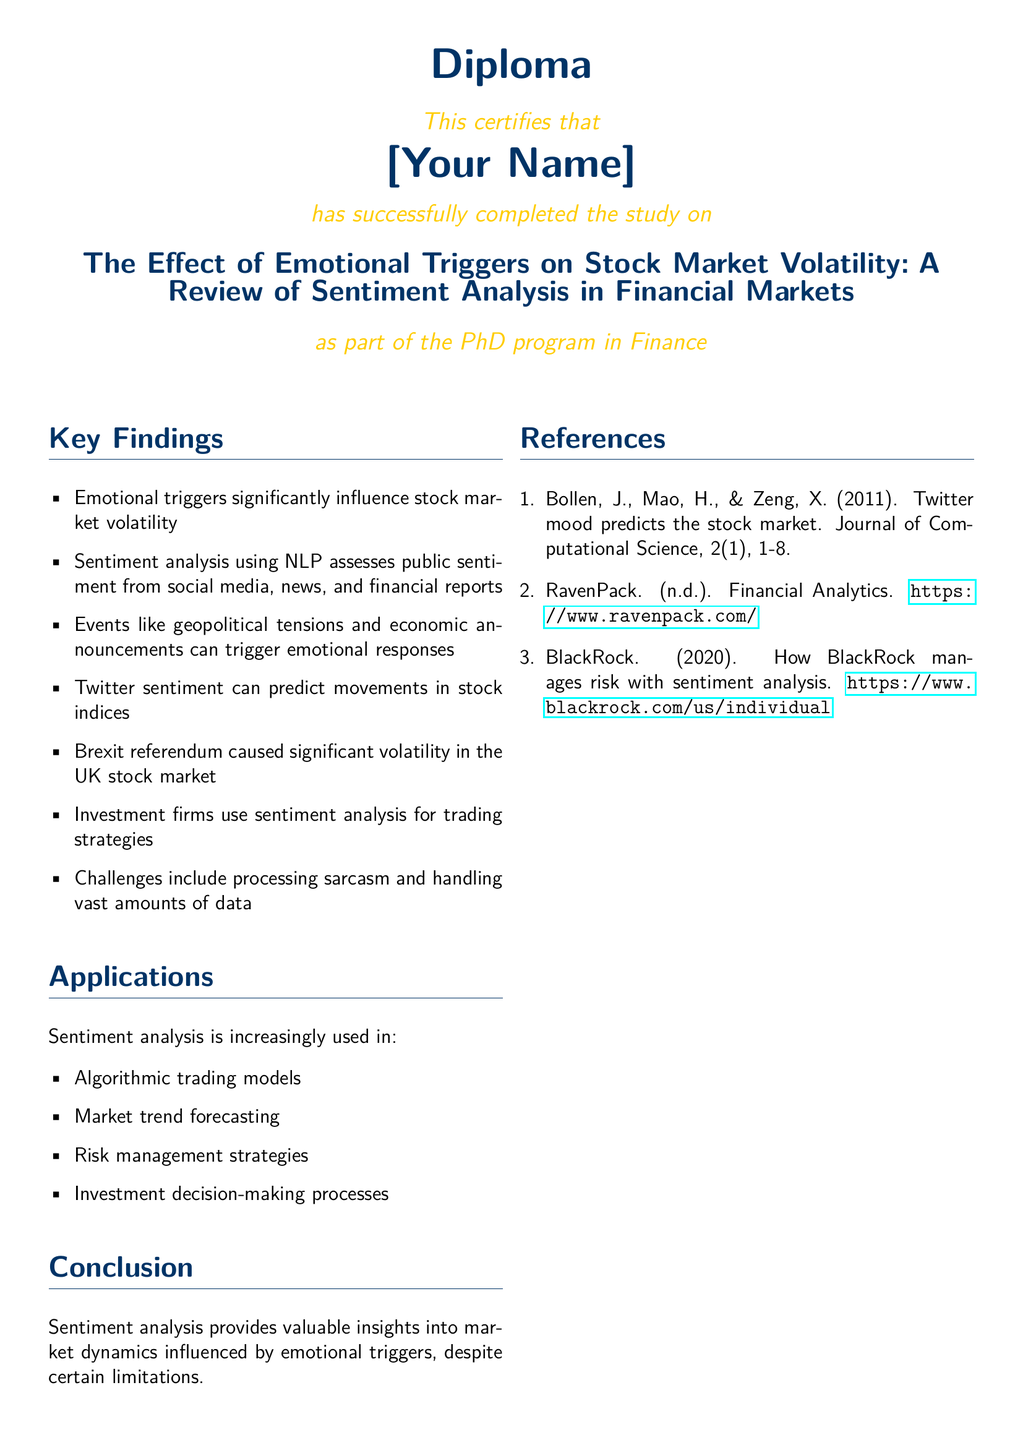what is the title of the study? The title of the study is presented at the top of the document in bold format.
Answer: The Effect of Emotional Triggers on Stock Market Volatility: A Review of Sentiment Analysis in Financial Markets who successfully completed the study? The name of the individual who completed the study is indicated as "[Your Name]."
Answer: [Your Name] which event caused significant volatility in the UK stock market? The document lists an event responsible for volatility under key findings and elaborates on its impact.
Answer: Brexit referendum what does sentiment analysis help in according to the applications section? The applications section includes multiple uses of sentiment analysis, describing its role in various areas.
Answer: Algorithmic trading models how many key findings are listed in the document? The number of key findings is determined by counting the bullet points in the key findings section.
Answer: seven who are the authors of the reference published in 2011? The authors' names are mentioned at the beginning of the reference section under the first reference.
Answer: Bollen, J., Mao, H., & Zeng, X when was the diploma awarded? The diploma states the date it was awarded as shown in the concluding section.
Answer: today what type of document is this? The document specifies its type in the title at the beginning.
Answer: Diploma 